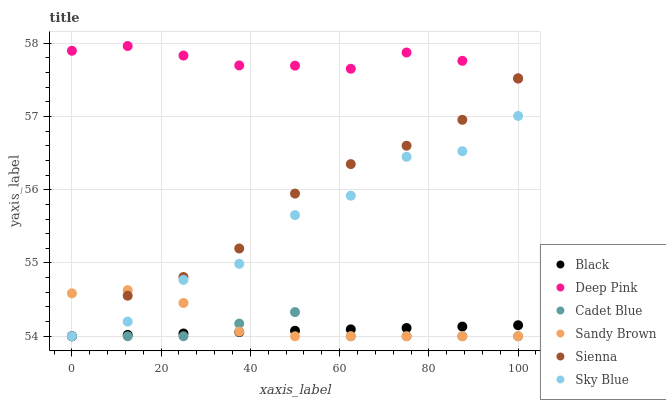Does Cadet Blue have the minimum area under the curve?
Answer yes or no. Yes. Does Deep Pink have the maximum area under the curve?
Answer yes or no. Yes. Does Sienna have the minimum area under the curve?
Answer yes or no. No. Does Sienna have the maximum area under the curve?
Answer yes or no. No. Is Black the smoothest?
Answer yes or no. Yes. Is Sky Blue the roughest?
Answer yes or no. Yes. Is Sienna the smoothest?
Answer yes or no. No. Is Sienna the roughest?
Answer yes or no. No. Does Cadet Blue have the lowest value?
Answer yes or no. Yes. Does Deep Pink have the lowest value?
Answer yes or no. No. Does Deep Pink have the highest value?
Answer yes or no. Yes. Does Sienna have the highest value?
Answer yes or no. No. Is Cadet Blue less than Deep Pink?
Answer yes or no. Yes. Is Deep Pink greater than Cadet Blue?
Answer yes or no. Yes. Does Cadet Blue intersect Sienna?
Answer yes or no. Yes. Is Cadet Blue less than Sienna?
Answer yes or no. No. Is Cadet Blue greater than Sienna?
Answer yes or no. No. Does Cadet Blue intersect Deep Pink?
Answer yes or no. No. 